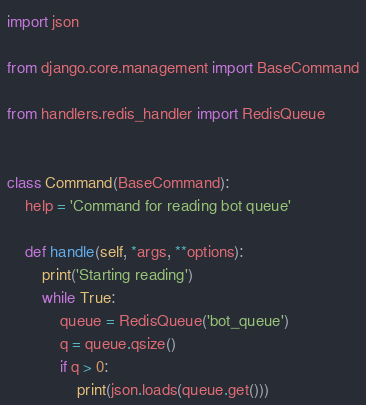<code> <loc_0><loc_0><loc_500><loc_500><_Python_>import json

from django.core.management import BaseCommand

from handlers.redis_handler import RedisQueue


class Command(BaseCommand):
    help = 'Command for reading bot queue'

    def handle(self, *args, **options):
        print('Starting reading')
        while True:
            queue = RedisQueue('bot_queue')
            q = queue.qsize()
            if q > 0:
                print(json.loads(queue.get()))
</code> 